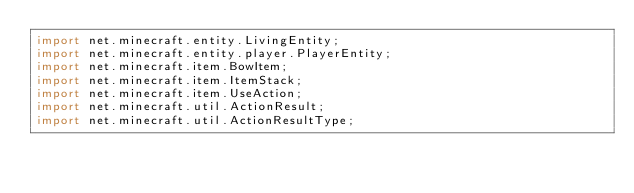<code> <loc_0><loc_0><loc_500><loc_500><_Java_>import net.minecraft.entity.LivingEntity;
import net.minecraft.entity.player.PlayerEntity;
import net.minecraft.item.BowItem;
import net.minecraft.item.ItemStack;
import net.minecraft.item.UseAction;
import net.minecraft.util.ActionResult;
import net.minecraft.util.ActionResultType;</code> 